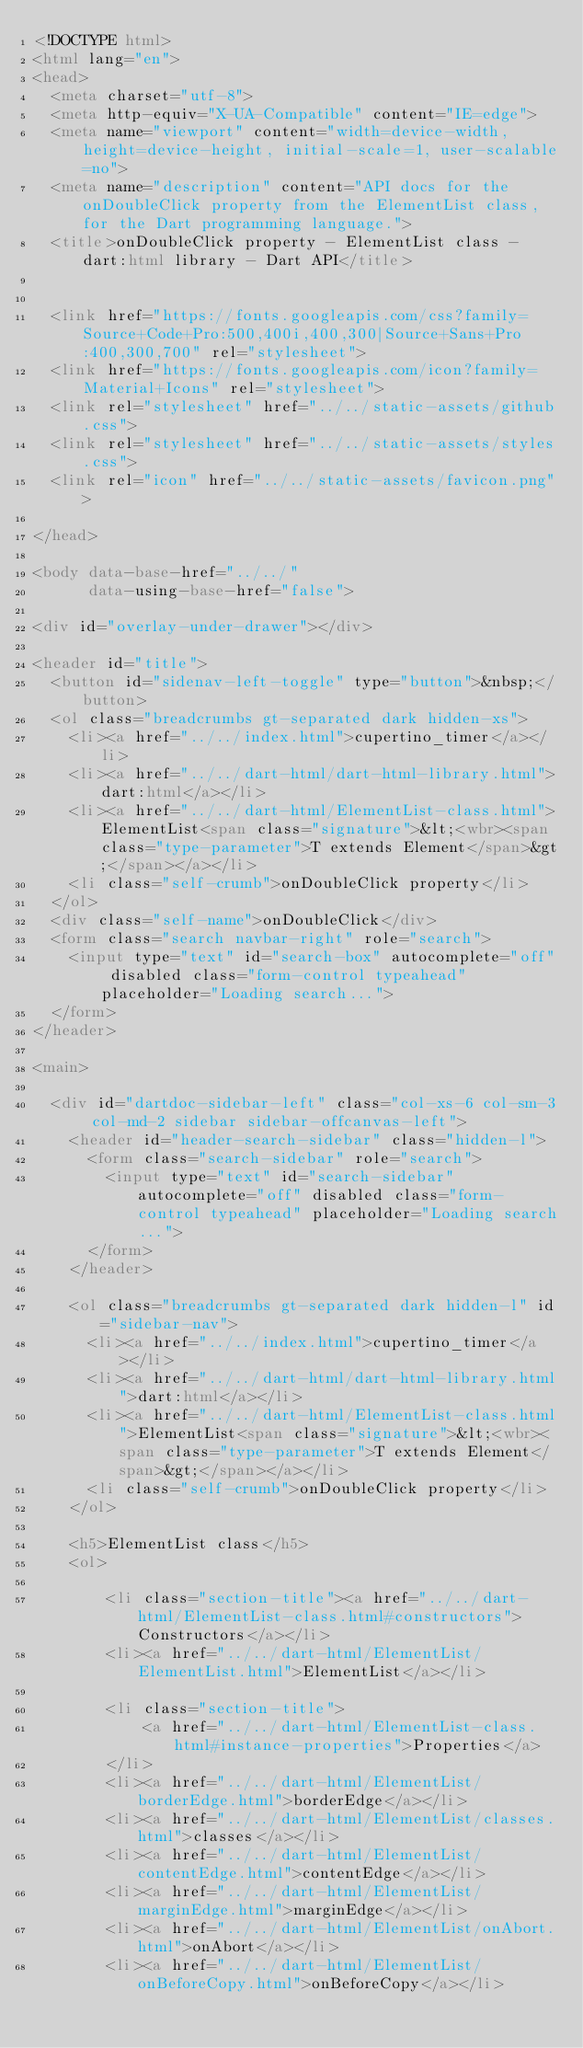Convert code to text. <code><loc_0><loc_0><loc_500><loc_500><_HTML_><!DOCTYPE html>
<html lang="en">
<head>
  <meta charset="utf-8">
  <meta http-equiv="X-UA-Compatible" content="IE=edge">
  <meta name="viewport" content="width=device-width, height=device-height, initial-scale=1, user-scalable=no">
  <meta name="description" content="API docs for the onDoubleClick property from the ElementList class, for the Dart programming language.">
  <title>onDoubleClick property - ElementList class - dart:html library - Dart API</title>

  
  <link href="https://fonts.googleapis.com/css?family=Source+Code+Pro:500,400i,400,300|Source+Sans+Pro:400,300,700" rel="stylesheet">
  <link href="https://fonts.googleapis.com/icon?family=Material+Icons" rel="stylesheet">
  <link rel="stylesheet" href="../../static-assets/github.css">
  <link rel="stylesheet" href="../../static-assets/styles.css">
  <link rel="icon" href="../../static-assets/favicon.png">

</head>

<body data-base-href="../../"
      data-using-base-href="false">

<div id="overlay-under-drawer"></div>

<header id="title">
  <button id="sidenav-left-toggle" type="button">&nbsp;</button>
  <ol class="breadcrumbs gt-separated dark hidden-xs">
    <li><a href="../../index.html">cupertino_timer</a></li>
    <li><a href="../../dart-html/dart-html-library.html">dart:html</a></li>
    <li><a href="../../dart-html/ElementList-class.html">ElementList<span class="signature">&lt;<wbr><span class="type-parameter">T extends Element</span>&gt;</span></a></li>
    <li class="self-crumb">onDoubleClick property</li>
  </ol>
  <div class="self-name">onDoubleClick</div>
  <form class="search navbar-right" role="search">
    <input type="text" id="search-box" autocomplete="off" disabled class="form-control typeahead" placeholder="Loading search...">
  </form>
</header>

<main>

  <div id="dartdoc-sidebar-left" class="col-xs-6 col-sm-3 col-md-2 sidebar sidebar-offcanvas-left">
    <header id="header-search-sidebar" class="hidden-l">
      <form class="search-sidebar" role="search">
        <input type="text" id="search-sidebar" autocomplete="off" disabled class="form-control typeahead" placeholder="Loading search...">
      </form>
    </header>
    
    <ol class="breadcrumbs gt-separated dark hidden-l" id="sidebar-nav">
      <li><a href="../../index.html">cupertino_timer</a></li>
      <li><a href="../../dart-html/dart-html-library.html">dart:html</a></li>
      <li><a href="../../dart-html/ElementList-class.html">ElementList<span class="signature">&lt;<wbr><span class="type-parameter">T extends Element</span>&gt;</span></a></li>
      <li class="self-crumb">onDoubleClick property</li>
    </ol>
    
    <h5>ElementList class</h5>
    <ol>
    
        <li class="section-title"><a href="../../dart-html/ElementList-class.html#constructors">Constructors</a></li>
        <li><a href="../../dart-html/ElementList/ElementList.html">ElementList</a></li>
    
        <li class="section-title">
            <a href="../../dart-html/ElementList-class.html#instance-properties">Properties</a>
        </li>
        <li><a href="../../dart-html/ElementList/borderEdge.html">borderEdge</a></li>
        <li><a href="../../dart-html/ElementList/classes.html">classes</a></li>
        <li><a href="../../dart-html/ElementList/contentEdge.html">contentEdge</a></li>
        <li><a href="../../dart-html/ElementList/marginEdge.html">marginEdge</a></li>
        <li><a href="../../dart-html/ElementList/onAbort.html">onAbort</a></li>
        <li><a href="../../dart-html/ElementList/onBeforeCopy.html">onBeforeCopy</a></li></code> 